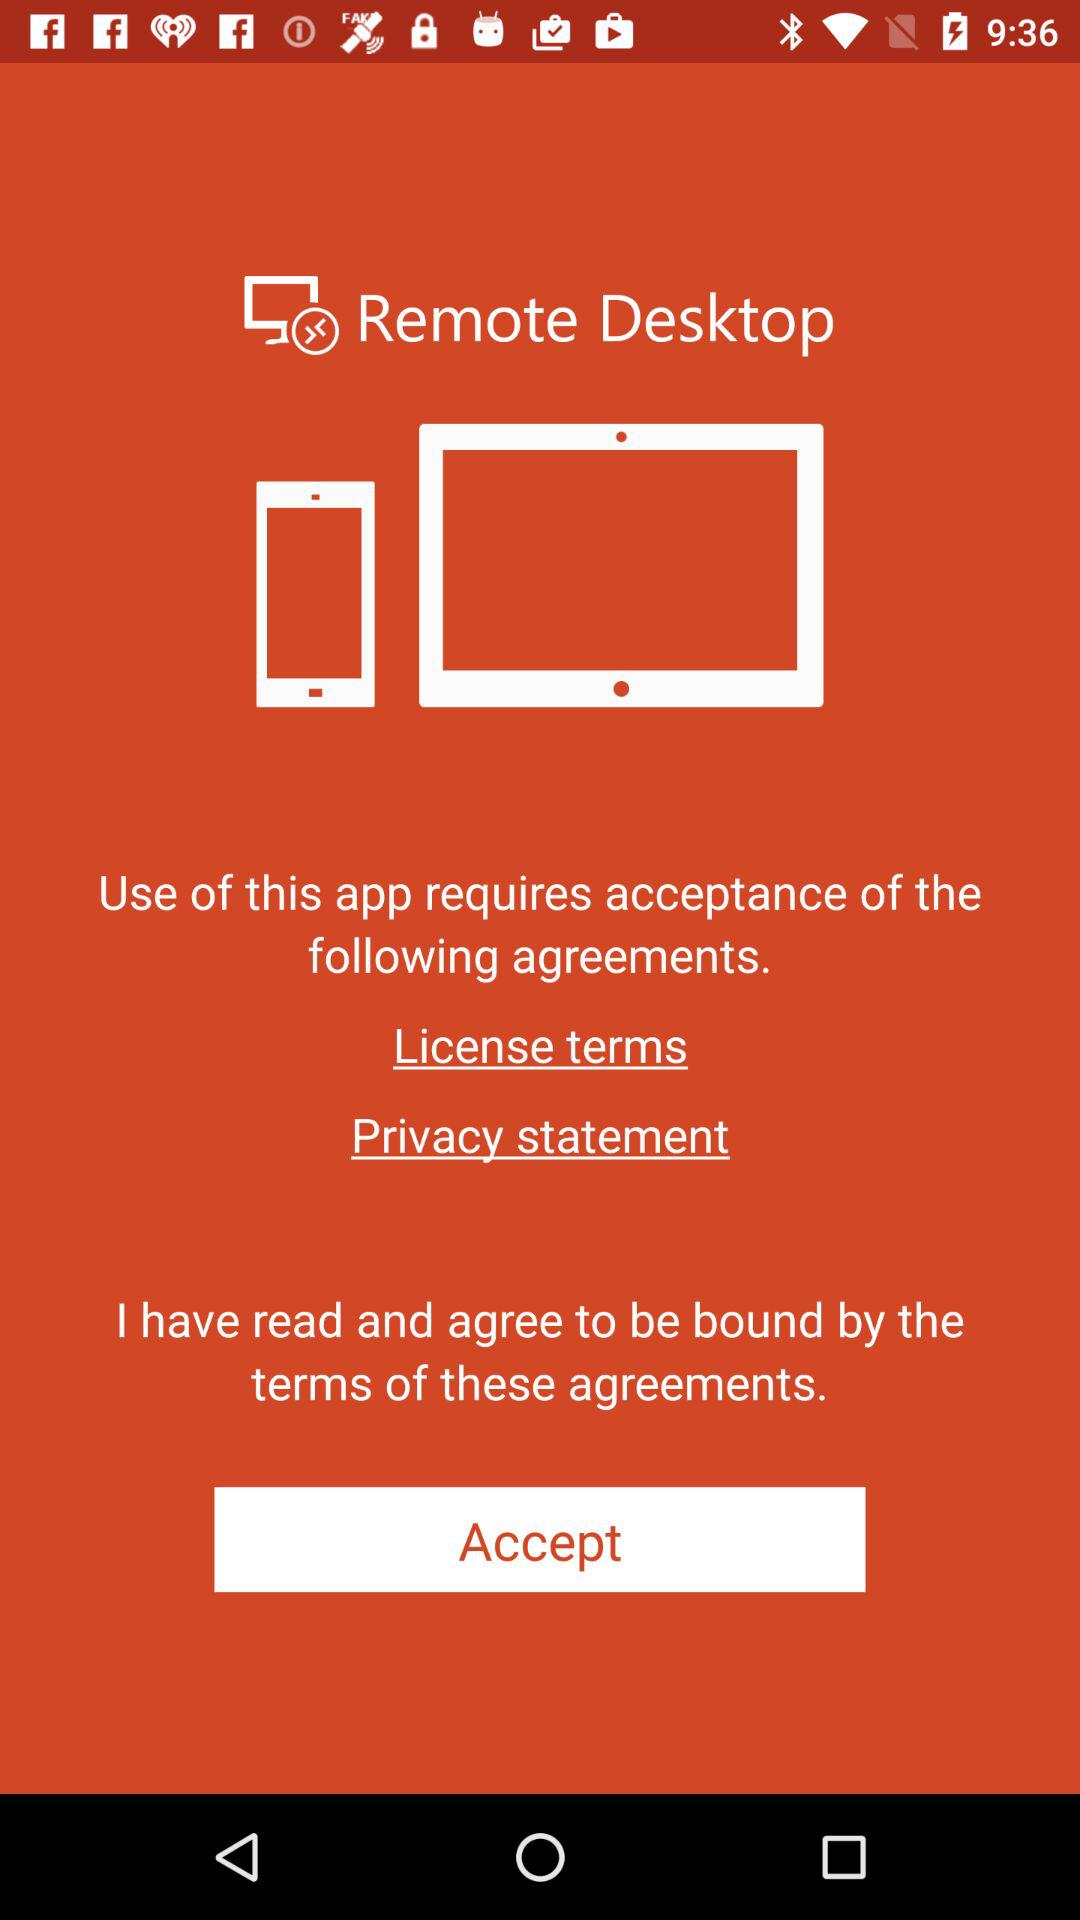What is the application name? The application name is "Remote Desktop". 